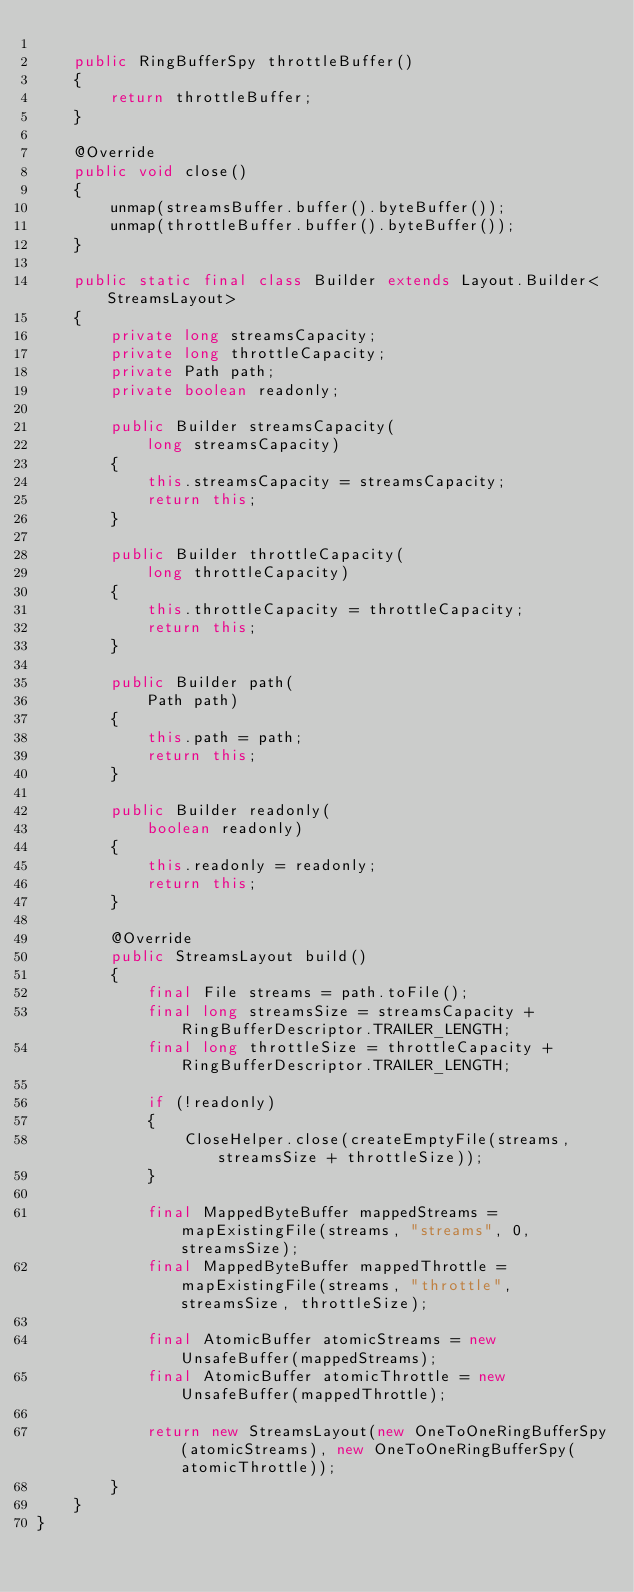Convert code to text. <code><loc_0><loc_0><loc_500><loc_500><_Java_>
    public RingBufferSpy throttleBuffer()
    {
        return throttleBuffer;
    }

    @Override
    public void close()
    {
        unmap(streamsBuffer.buffer().byteBuffer());
        unmap(throttleBuffer.buffer().byteBuffer());
    }

    public static final class Builder extends Layout.Builder<StreamsLayout>
    {
        private long streamsCapacity;
        private long throttleCapacity;
        private Path path;
        private boolean readonly;

        public Builder streamsCapacity(
            long streamsCapacity)
        {
            this.streamsCapacity = streamsCapacity;
            return this;
        }

        public Builder throttleCapacity(
            long throttleCapacity)
        {
            this.throttleCapacity = throttleCapacity;
            return this;
        }

        public Builder path(
            Path path)
        {
            this.path = path;
            return this;
        }

        public Builder readonly(
            boolean readonly)
        {
            this.readonly = readonly;
            return this;
        }

        @Override
        public StreamsLayout build()
        {
            final File streams = path.toFile();
            final long streamsSize = streamsCapacity + RingBufferDescriptor.TRAILER_LENGTH;
            final long throttleSize = throttleCapacity + RingBufferDescriptor.TRAILER_LENGTH;

            if (!readonly)
            {
                CloseHelper.close(createEmptyFile(streams, streamsSize + throttleSize));
            }

            final MappedByteBuffer mappedStreams = mapExistingFile(streams, "streams", 0, streamsSize);
            final MappedByteBuffer mappedThrottle = mapExistingFile(streams, "throttle", streamsSize, throttleSize);

            final AtomicBuffer atomicStreams = new UnsafeBuffer(mappedStreams);
            final AtomicBuffer atomicThrottle = new UnsafeBuffer(mappedThrottle);

            return new StreamsLayout(new OneToOneRingBufferSpy(atomicStreams), new OneToOneRingBufferSpy(atomicThrottle));
        }
    }
}
</code> 